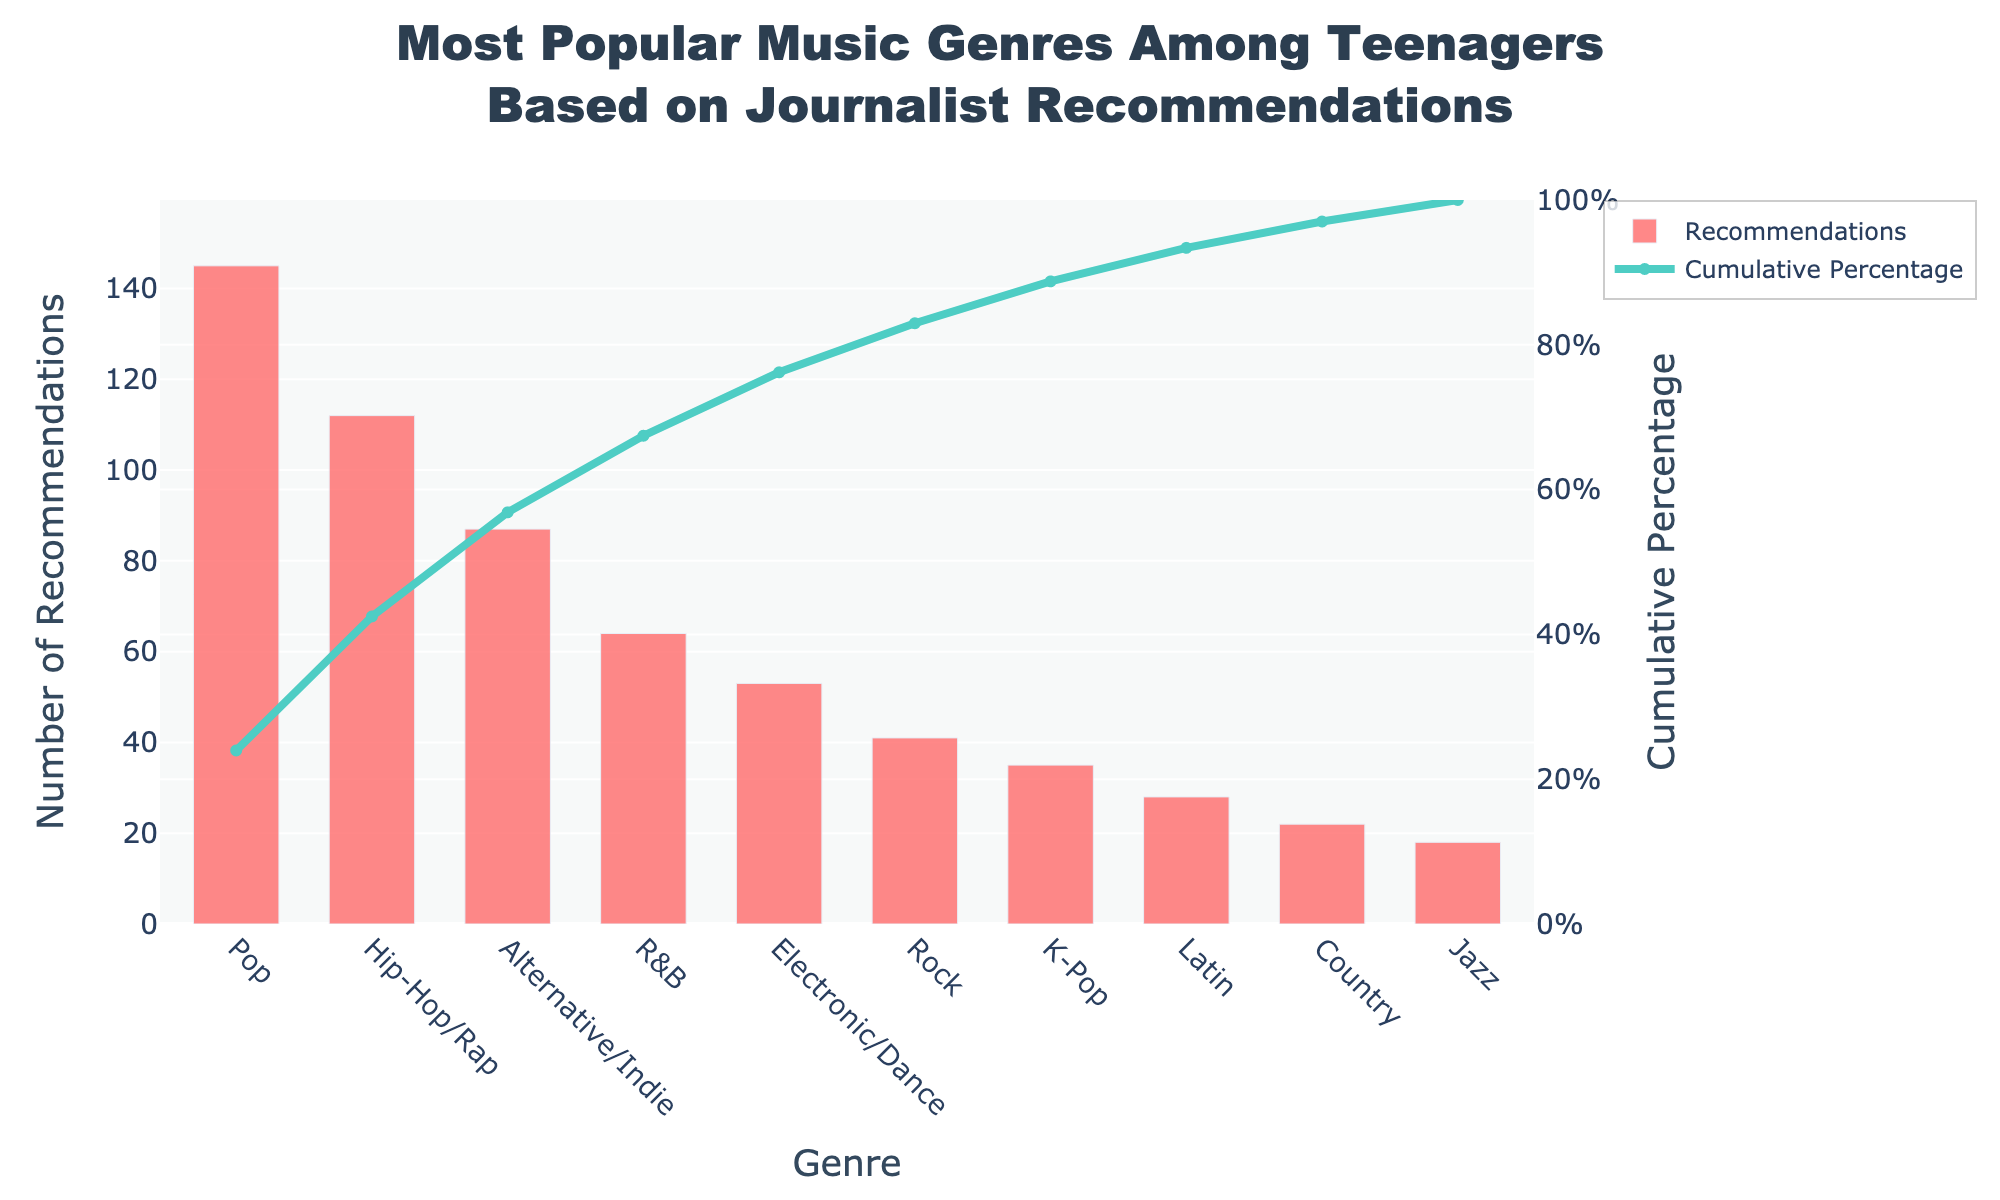What is the title of the chart? The title is usually located at the top of the chart. In this chart, it reads, "Most Popular Music Genres Among Teenagers Based on Journalist Recommendations".
Answer: Most Popular Music Genres Among Teenagers Based on Journalist Recommendations How many genres have received more than 50 recommendations? Look at the bar heights for genres and count those above the 50 mark on the y-axis. Pop, Hip-Hop/Rap, Alternative/Indie, R&B, and Electronic/Dance exceed 50.
Answer: 5 Which genre has the highest number of recommendations? The highest bar on the chart represents the genre with the most recommendations. Here, the Pop genre has the tallest bar with 145 recommendations.
Answer: Pop What is the cumulative percentage for the Hip-Hop/Rap genre? Check the cumulative percentage line at the point where it intersects with the Hip-Hop/Rap genre. The line chart shows the cumulative percentage on its y-axis. For Hip-Hop/Rap, the cumulative percentage is 59.6%.
Answer: 59.6% Which two genres together account for approximately 75% of the total recommendations? Follow the cumulative percentage line to see where it reaches around 75%. Hip-Hop/Rap reaches 59.6%, and Alternative/Indie adds up more, but not quite 75%. With R&B included, it exceeds 75%. Thus, Pop, Hip-Hop/Rap, and Alternative/Indie together cross 75%.
Answer: Pop and Hip-Hop/Rap How many recommendations does the least popular genre have? Locate the shortest bar on the chart which represents Jazz. The bar has a height corresponding to the least number of recommendations, which is 18.
Answer: 18 What is the difference in recommendations between Pop and Rock genres? Subtract the number of recommendations for Rock from those for Pop: 145 (Pop) - 41 (Rock) = 104.
Answer: 104 What is the cumulative percentage after including the Alternative/Indie genre? Locate the endpoint of the cumulative percentage line at the genre Alternative/Indie. The cumulative percentage is 76.5%.
Answer: 76.5% How many genres have fewer than 30 recommendations? Count bars that are shorter than the 30 mark on the y-axis. Latin, Country, and Jazz have fewer than 30 recommendations.
Answer: 3 What percentage of the total recommendations is covered by the three least popular genres? Sum the recommendations for the least popular genres (Latin: 28, Country: 22, Jazz: 18), which totals 68. Divide this by the overall total (605) and multiply by 100: (68/605)*100 ≈ 11.2%.
Answer: 11.2% 